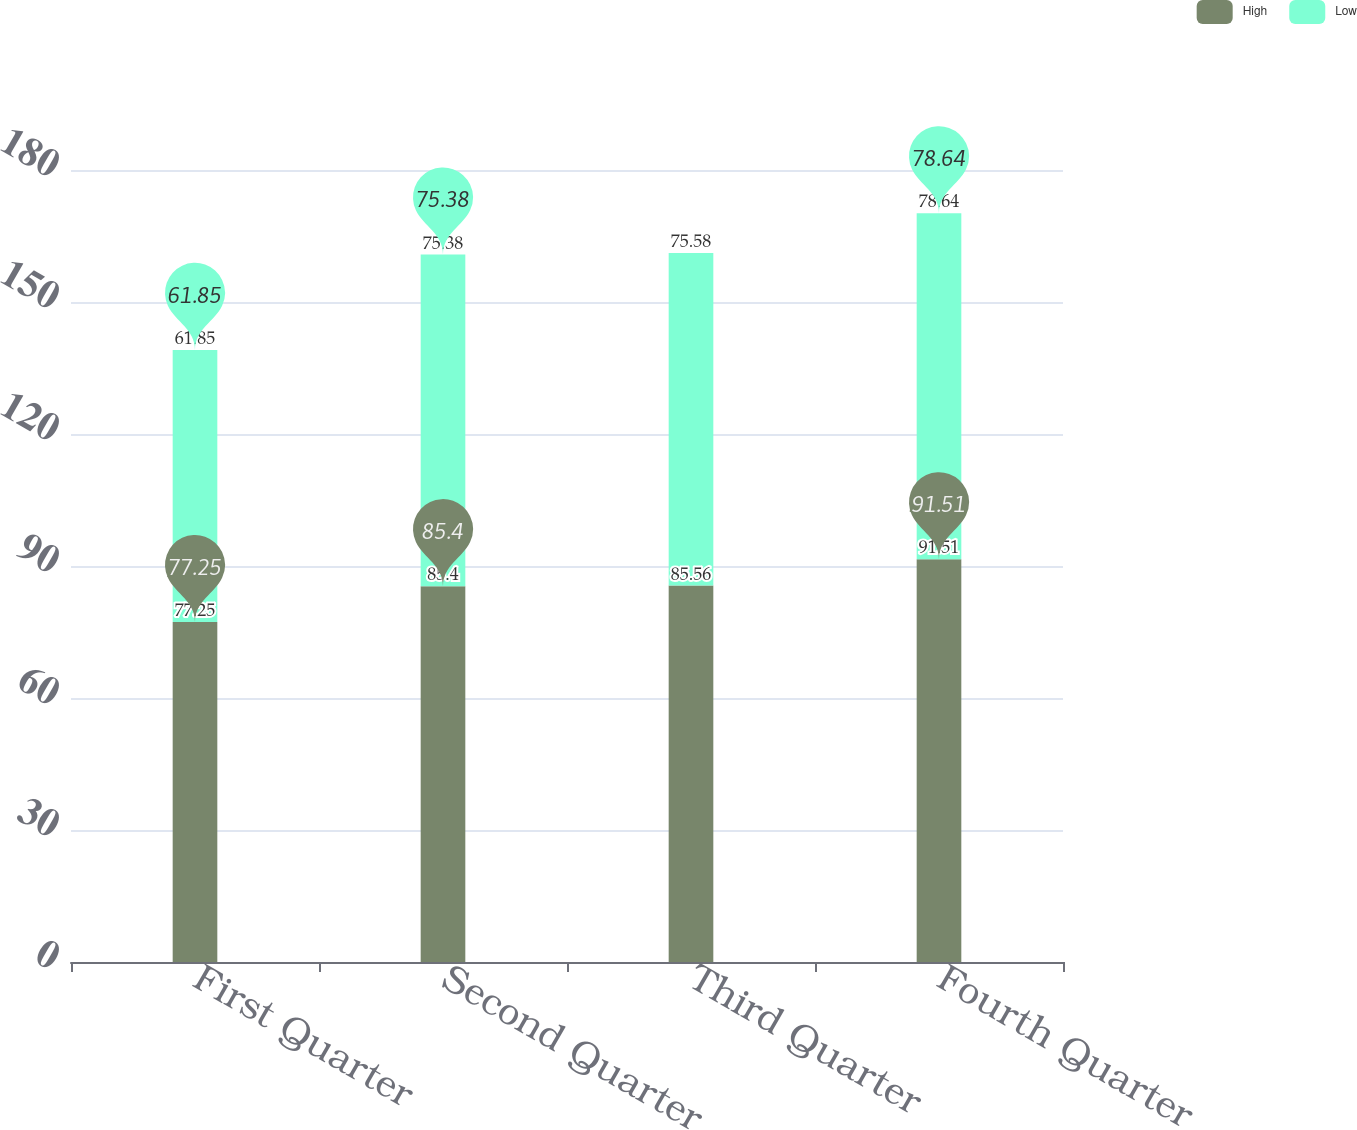Convert chart to OTSL. <chart><loc_0><loc_0><loc_500><loc_500><stacked_bar_chart><ecel><fcel>First Quarter<fcel>Second Quarter<fcel>Third Quarter<fcel>Fourth Quarter<nl><fcel>High<fcel>77.25<fcel>85.4<fcel>85.56<fcel>91.51<nl><fcel>Low<fcel>61.85<fcel>75.38<fcel>75.58<fcel>78.64<nl></chart> 